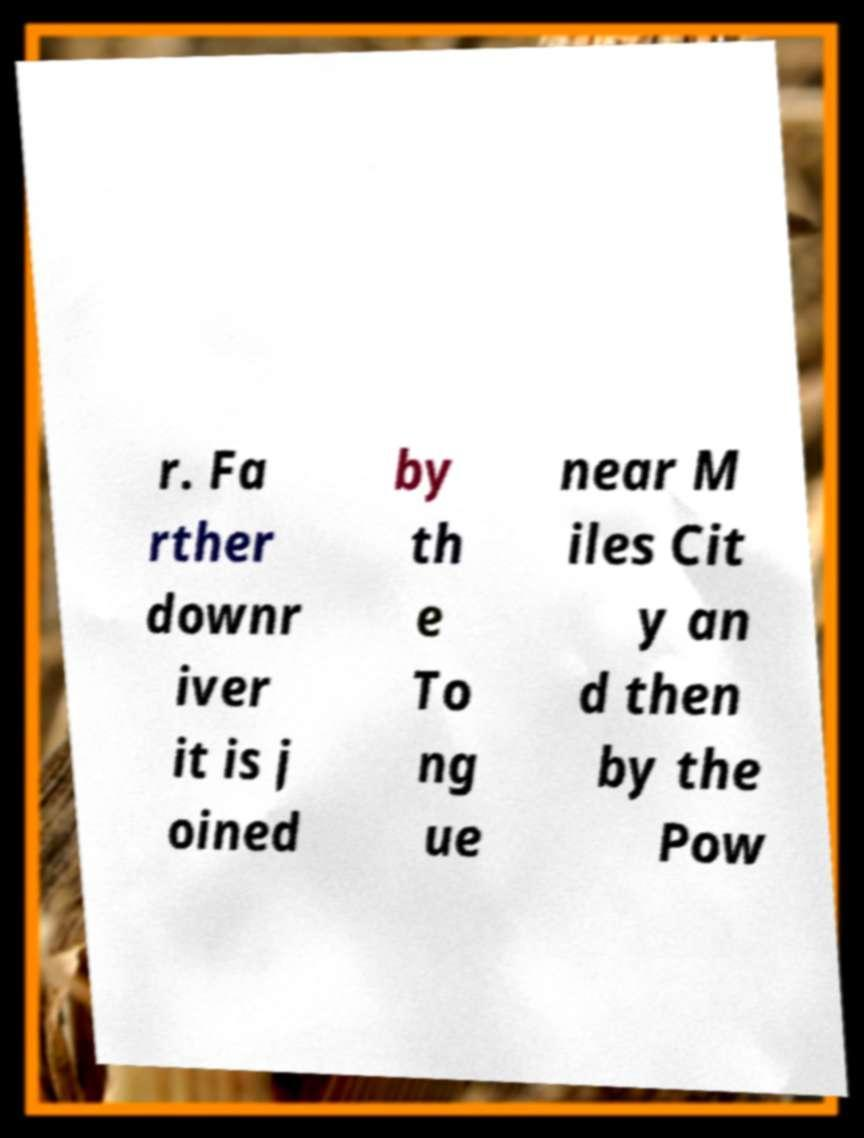There's text embedded in this image that I need extracted. Can you transcribe it verbatim? r. Fa rther downr iver it is j oined by th e To ng ue near M iles Cit y an d then by the Pow 